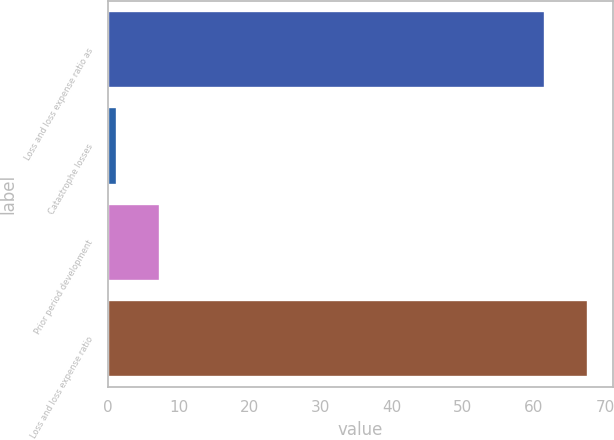Convert chart to OTSL. <chart><loc_0><loc_0><loc_500><loc_500><bar_chart><fcel>Loss and loss expense ratio as<fcel>Catastrophe losses<fcel>Prior period development<fcel>Loss and loss expense ratio<nl><fcel>61.6<fcel>1.3<fcel>7.38<fcel>67.68<nl></chart> 